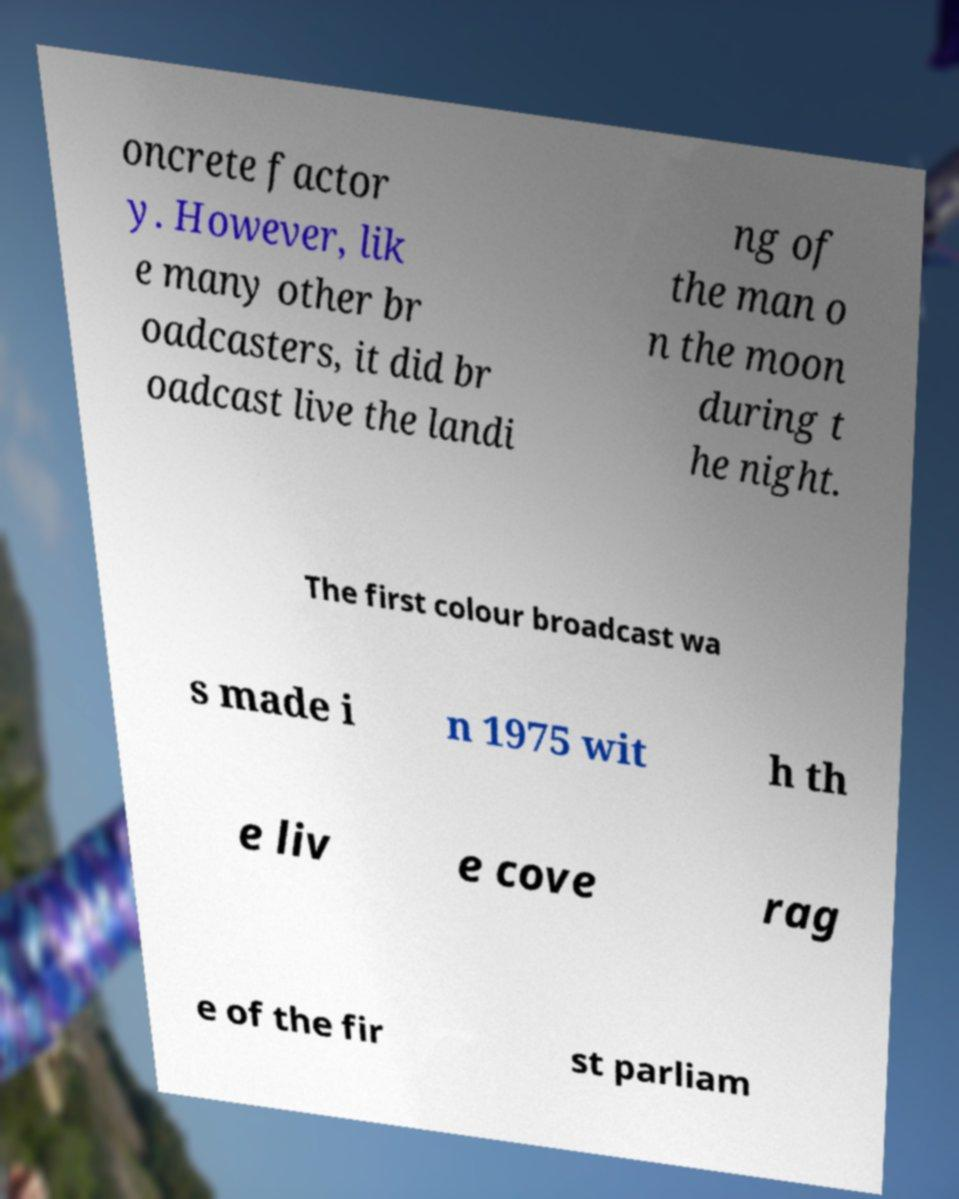Could you assist in decoding the text presented in this image and type it out clearly? oncrete factor y. However, lik e many other br oadcasters, it did br oadcast live the landi ng of the man o n the moon during t he night. The first colour broadcast wa s made i n 1975 wit h th e liv e cove rag e of the fir st parliam 